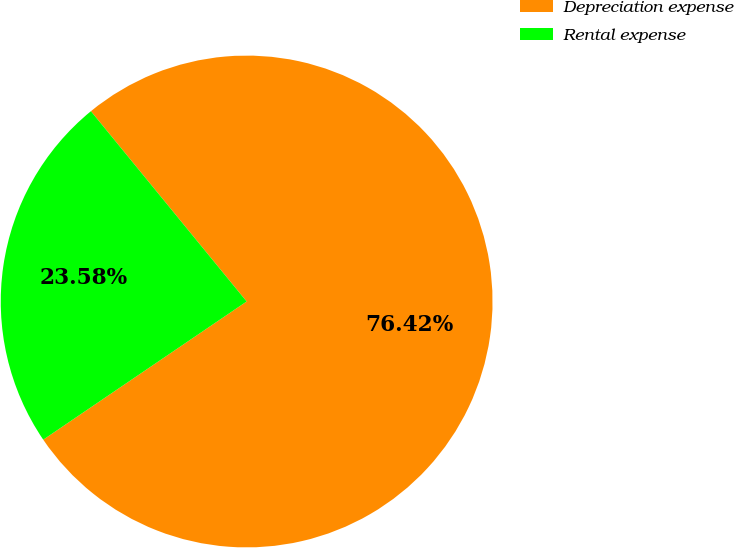<chart> <loc_0><loc_0><loc_500><loc_500><pie_chart><fcel>Depreciation expense<fcel>Rental expense<nl><fcel>76.42%<fcel>23.58%<nl></chart> 